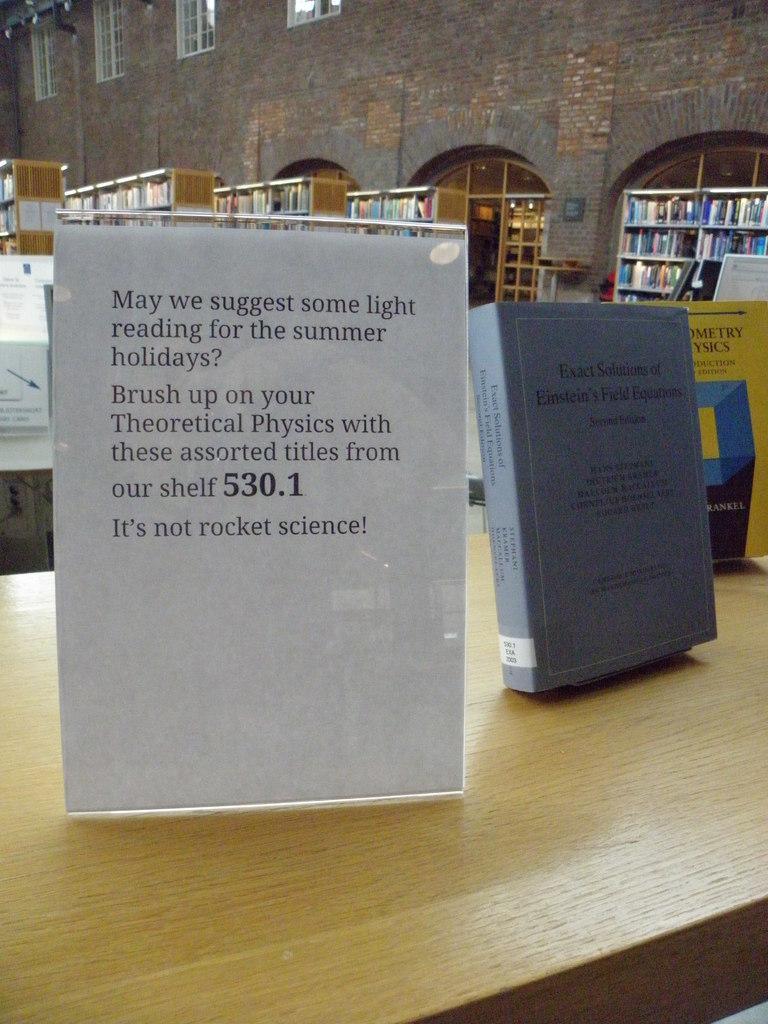Please provide a concise description of this image. As we can see in the image there is a building, cracks filled with books, tables, posters and windows. 